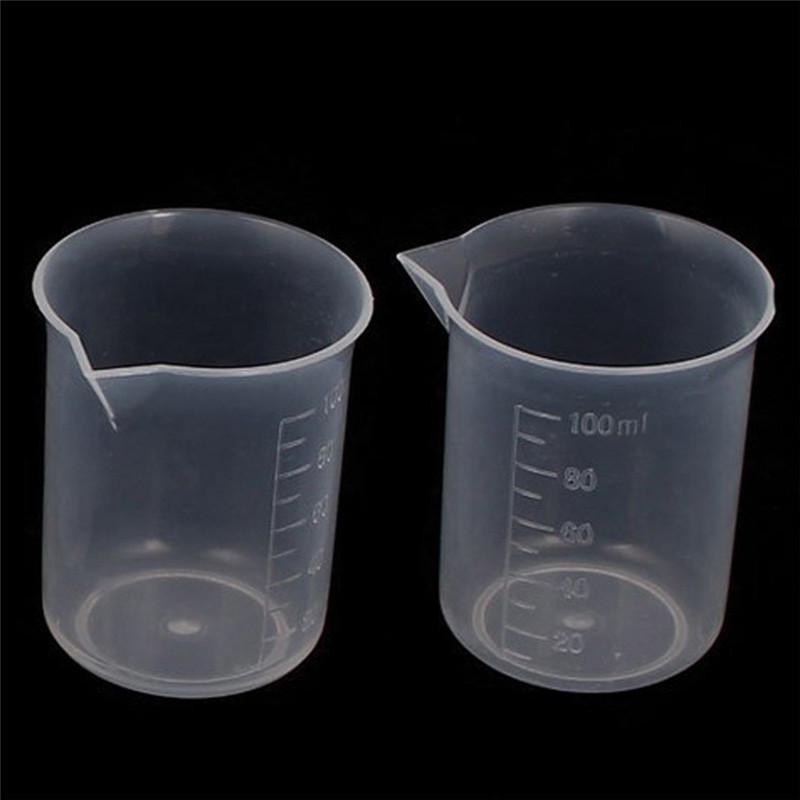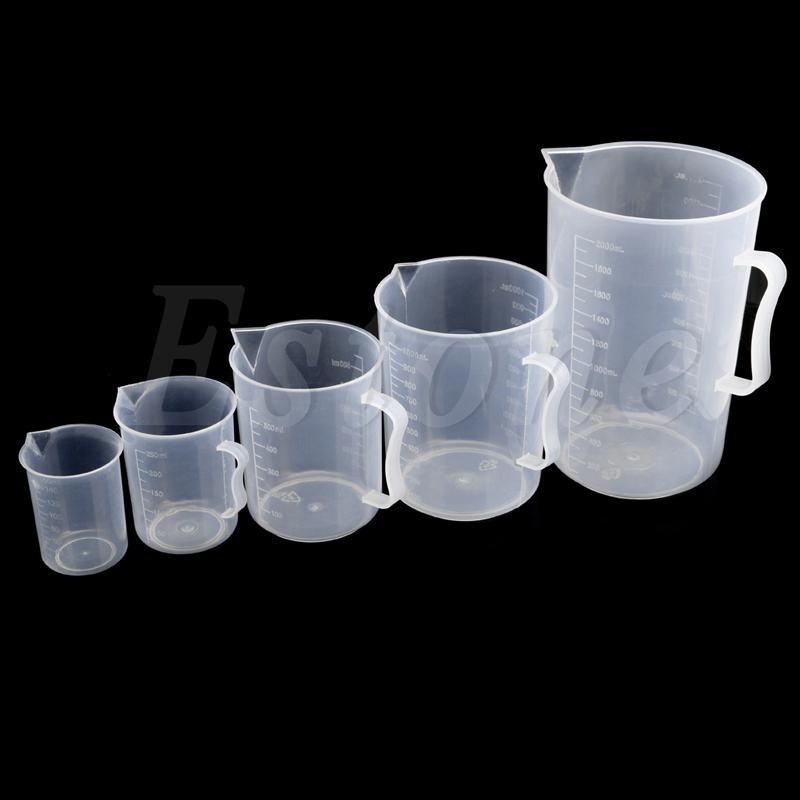The first image is the image on the left, the second image is the image on the right. Considering the images on both sides, is "One image contains exactly 2 measuring cups." valid? Answer yes or no. Yes. 